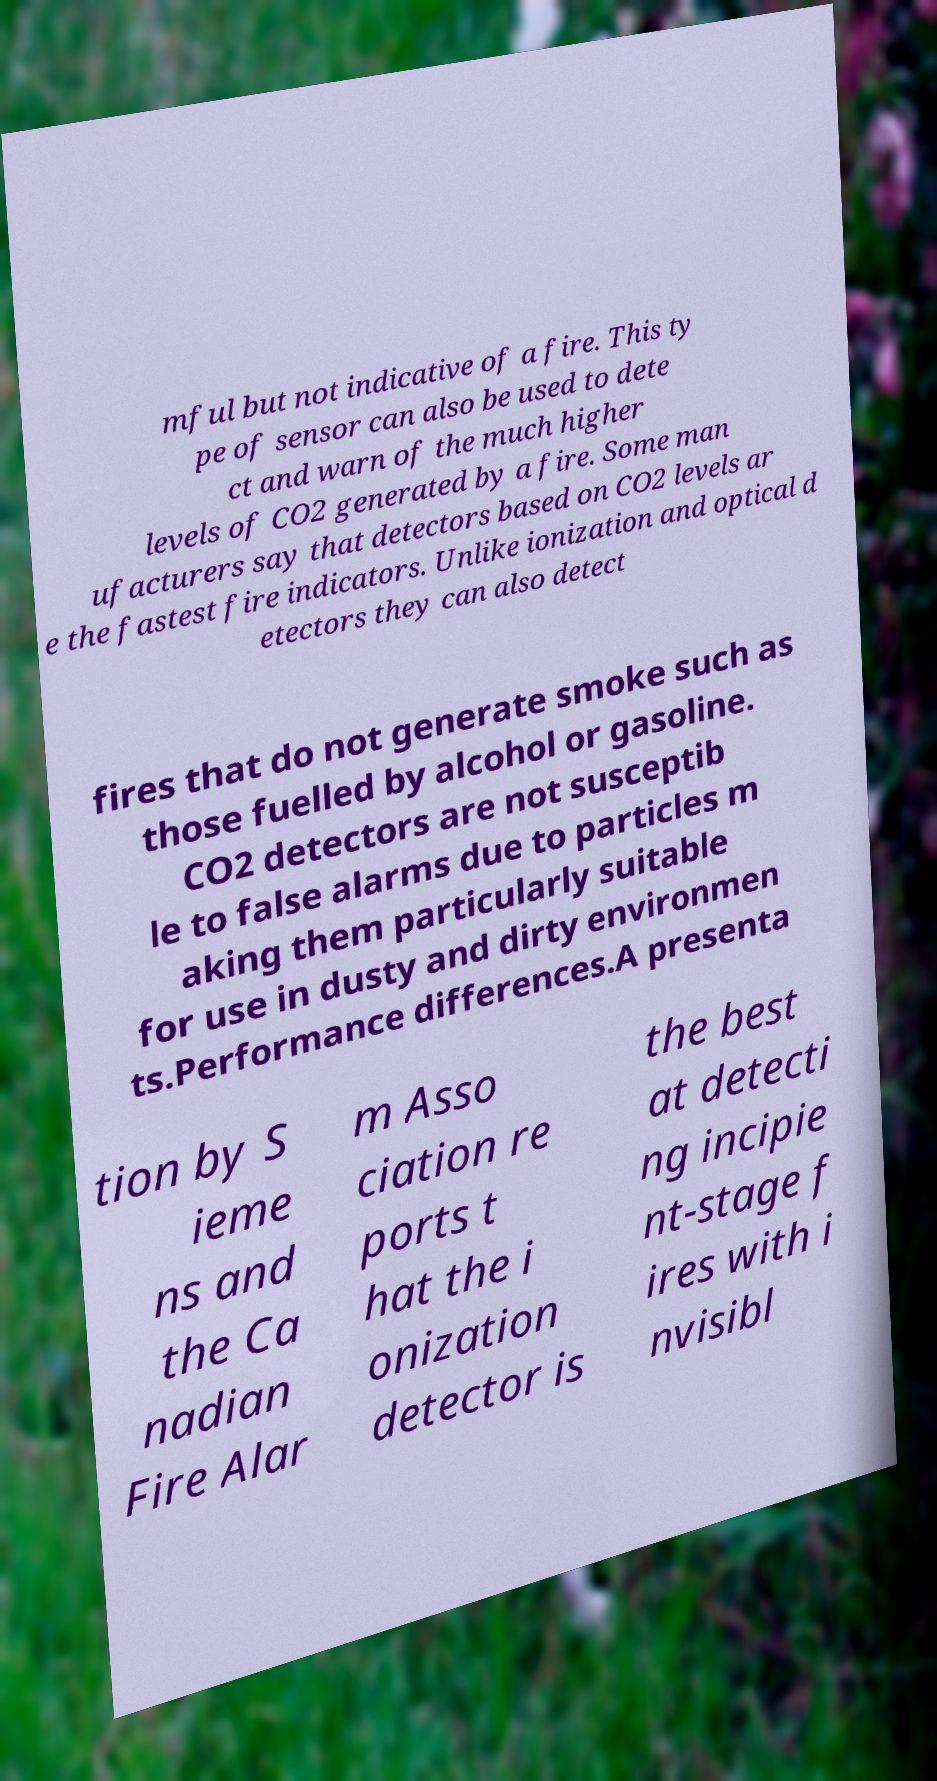Can you read and provide the text displayed in the image?This photo seems to have some interesting text. Can you extract and type it out for me? mful but not indicative of a fire. This ty pe of sensor can also be used to dete ct and warn of the much higher levels of CO2 generated by a fire. Some man ufacturers say that detectors based on CO2 levels ar e the fastest fire indicators. Unlike ionization and optical d etectors they can also detect fires that do not generate smoke such as those fuelled by alcohol or gasoline. CO2 detectors are not susceptib le to false alarms due to particles m aking them particularly suitable for use in dusty and dirty environmen ts.Performance differences.A presenta tion by S ieme ns and the Ca nadian Fire Alar m Asso ciation re ports t hat the i onization detector is the best at detecti ng incipie nt-stage f ires with i nvisibl 